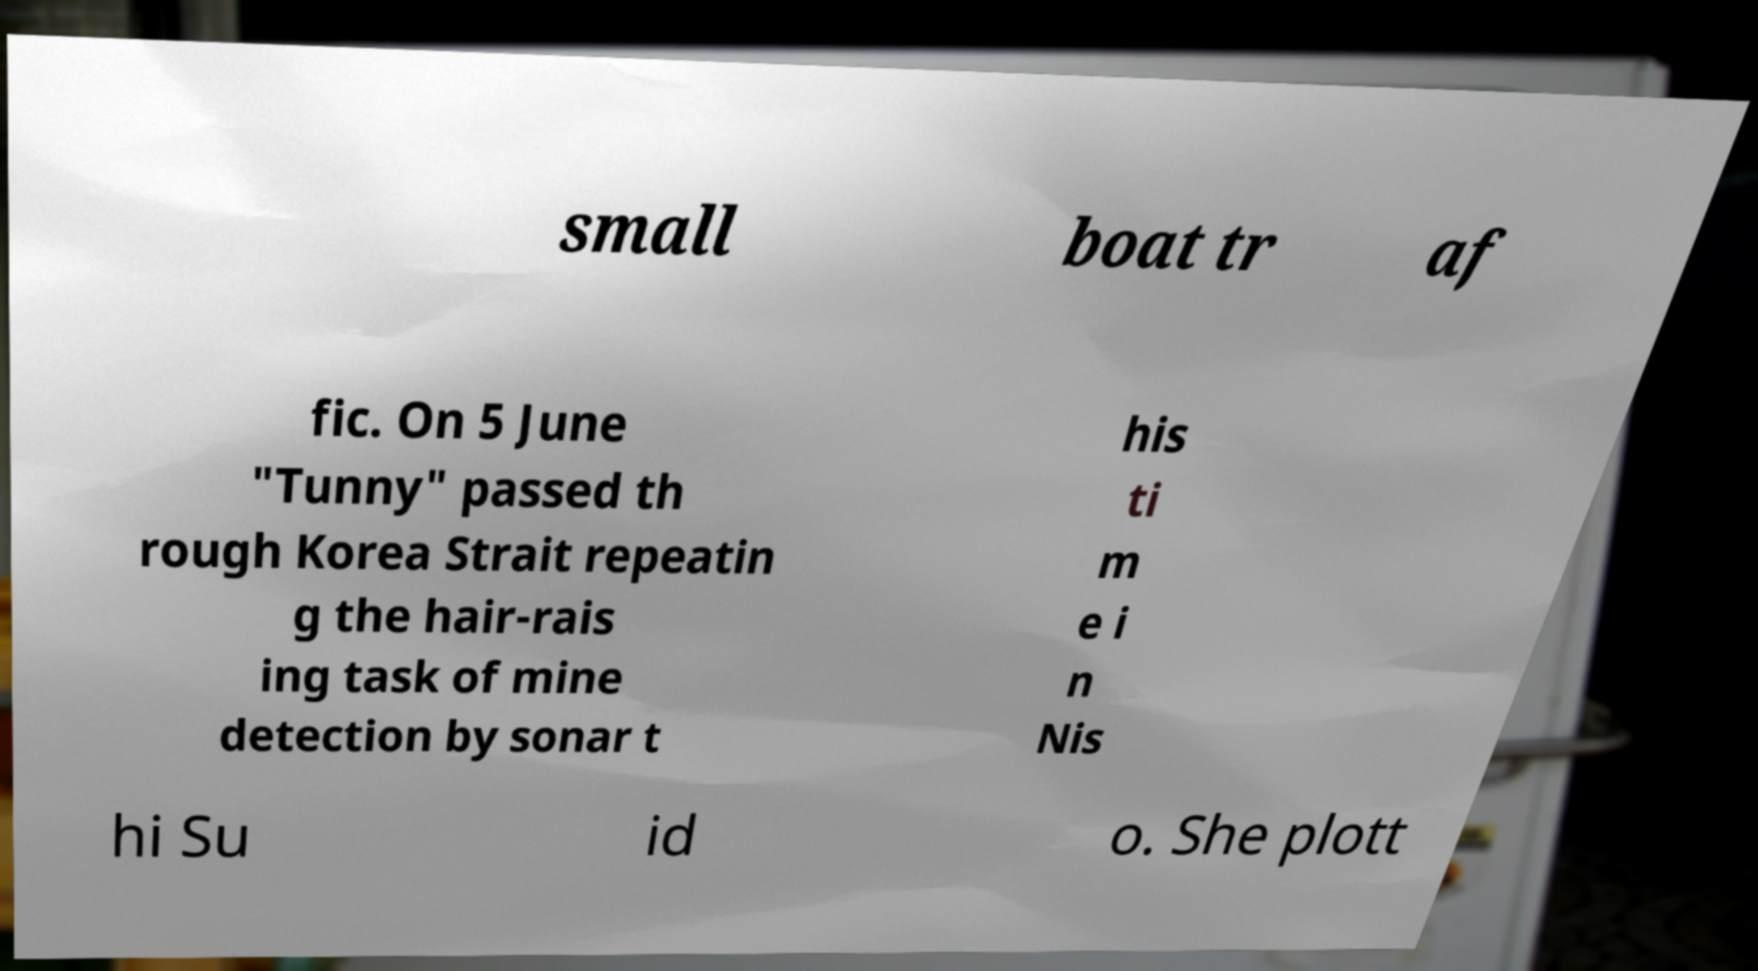Please read and relay the text visible in this image. What does it say? small boat tr af fic. On 5 June "Tunny" passed th rough Korea Strait repeatin g the hair-rais ing task of mine detection by sonar t his ti m e i n Nis hi Su id o. She plott 